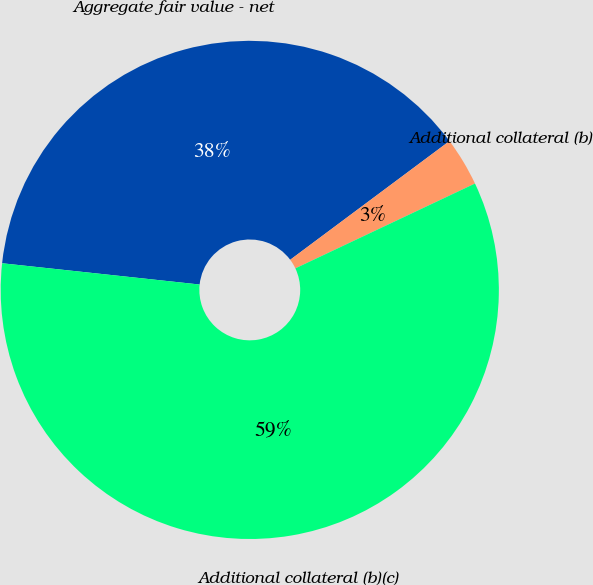Convert chart to OTSL. <chart><loc_0><loc_0><loc_500><loc_500><pie_chart><fcel>Aggregate fair value - net<fcel>Additional collateral (b)<fcel>Additional collateral (b)(c)<nl><fcel>38.1%<fcel>3.17%<fcel>58.73%<nl></chart> 